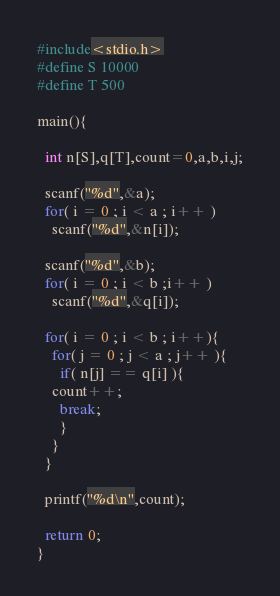<code> <loc_0><loc_0><loc_500><loc_500><_C_>#include<stdio.h>
#define S 10000
#define T 500

main(){

  int n[S],q[T],count=0,a,b,i,j;

  scanf("%d",&a);
  for( i = 0 ; i < a ; i++ )
    scanf("%d",&n[i]);

  scanf("%d",&b);
  for( i = 0 ; i < b ;i++ )
    scanf("%d",&q[i]);

  for( i = 0 ; i < b ; i++){
    for( j = 0 ; j < a ; j++ ){
      if( n[j] == q[i] ){
	count++;
	  break;
      }
    }
  }

  printf("%d\n",count);
  
  return 0;
}</code> 